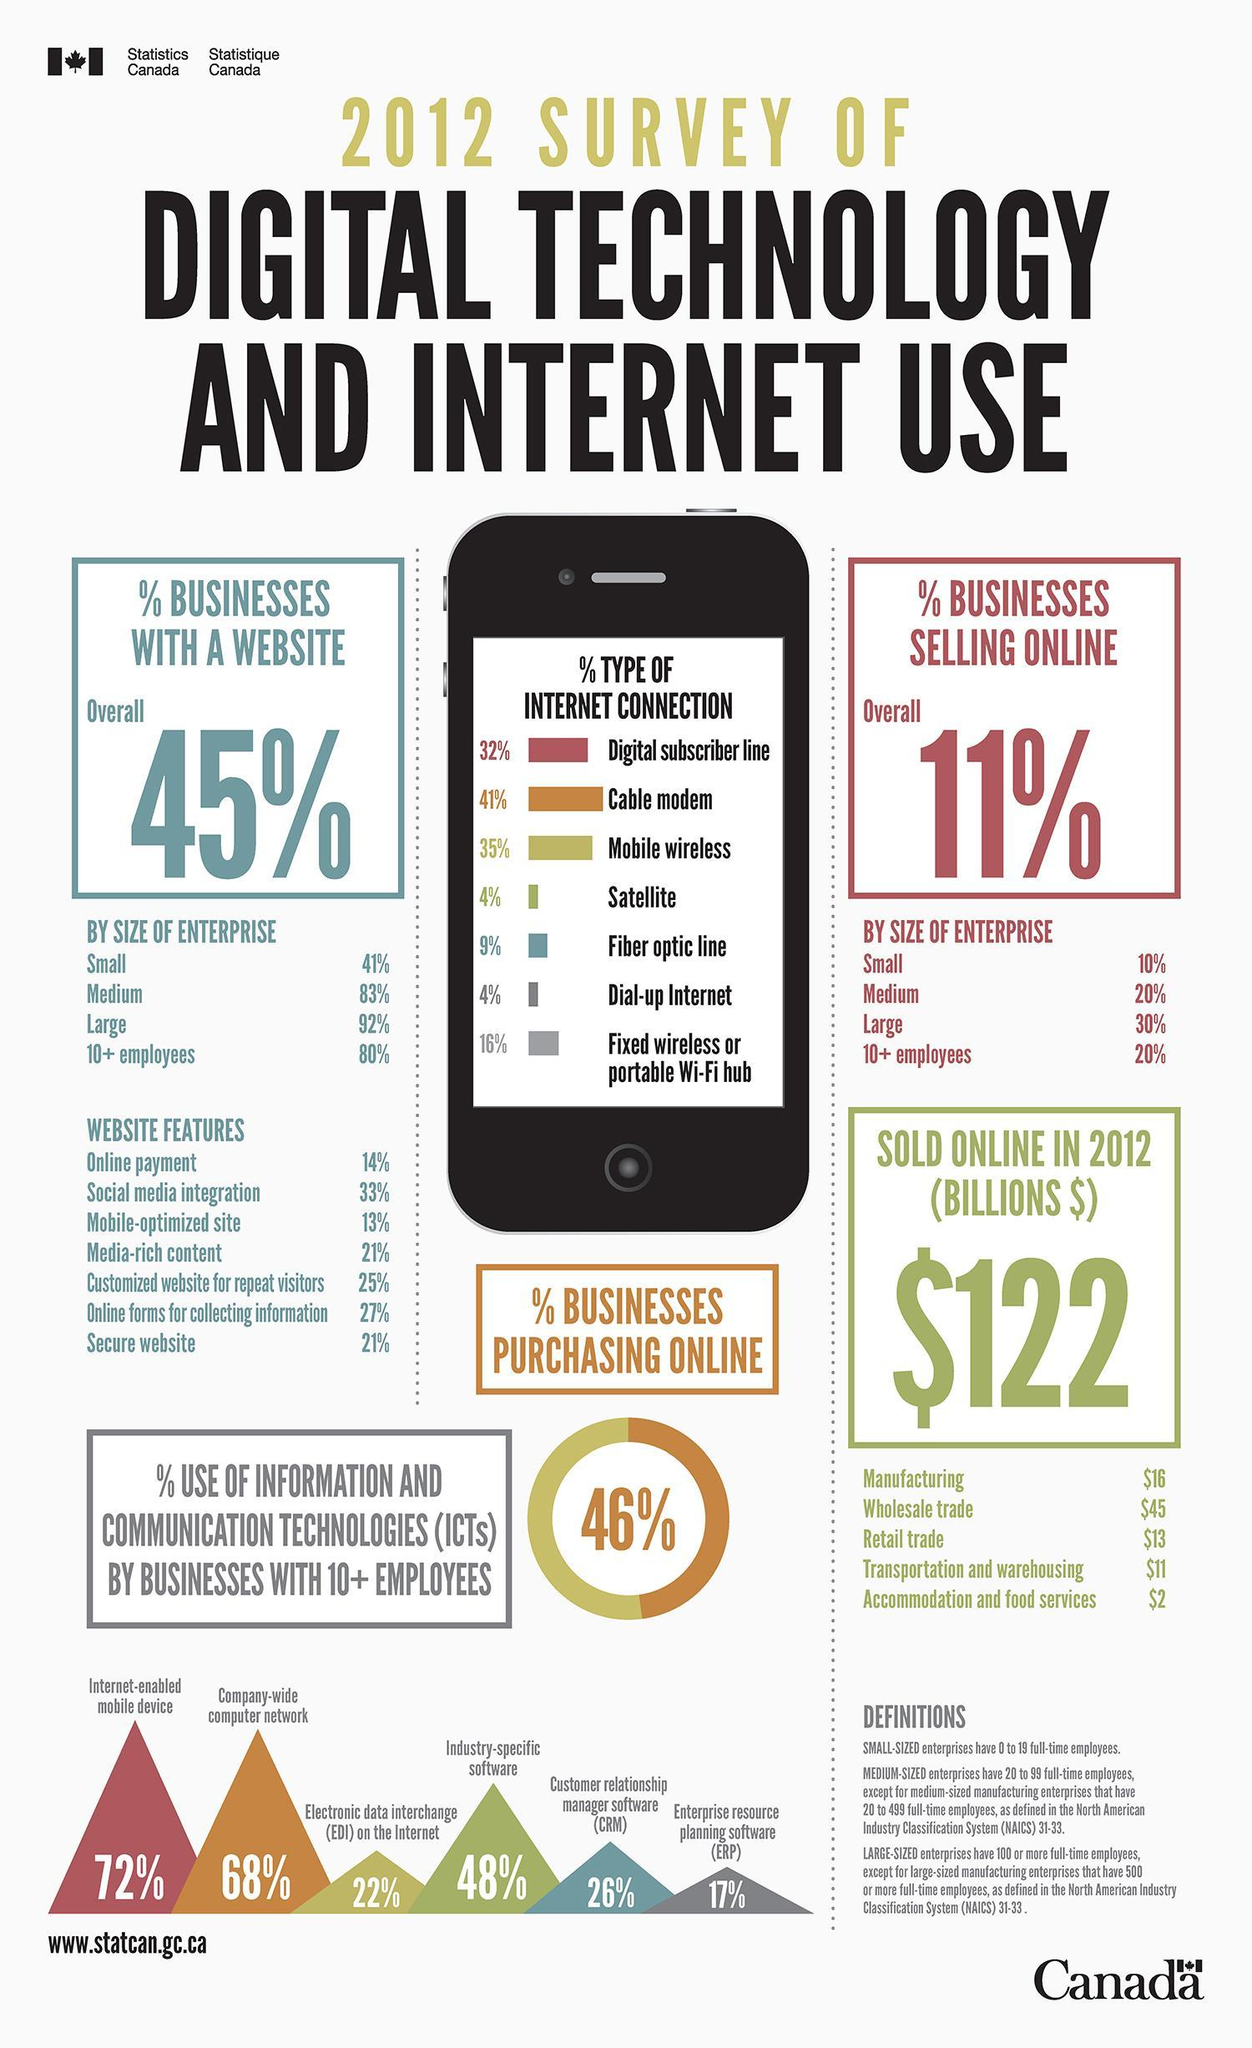What percentage of Mobile wireless type internet connection is used by the businesses as per the 2012 survey in Canada?
Answer the question with a short phrase. 35% What percentage of businesses in Canada have media-rich content in websites as per the 2012 survey? 21% What percentage of businesses in Canada have a online payment options in their websites as per the 2012 survey? 14% Which internet connection type is used by majority of the businesses as per the 2012 survey in Canada? Cable Modem Which internet connection type is used least in the businesses as per the 2012 survey in Canada? Satellite, Dial-up Internet Which size of enterprises in canada have highest percentage of online businesses sales? Large What is the percentage use of ERP software by businesses with 10+ employees in Canada as per the 2012 survey? 17% What percentage of businesses in Canada have secure websites as per the 2012 survey? 21% What is the percentage use of Industry-specific software by businesses with 10+ employees in Canada as per the 2012 survey? 48% What is the percentage of online businesses sales in medium scale enterprises in Canada as per the 2012 survey? 20% 